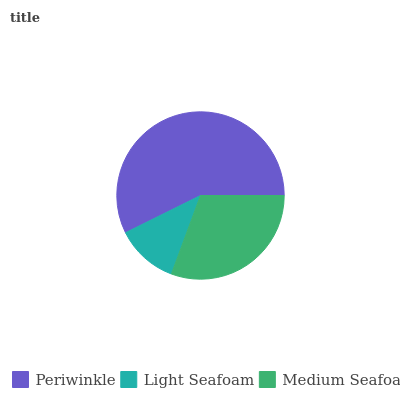Is Light Seafoam the minimum?
Answer yes or no. Yes. Is Periwinkle the maximum?
Answer yes or no. Yes. Is Medium Seafoam the minimum?
Answer yes or no. No. Is Medium Seafoam the maximum?
Answer yes or no. No. Is Medium Seafoam greater than Light Seafoam?
Answer yes or no. Yes. Is Light Seafoam less than Medium Seafoam?
Answer yes or no. Yes. Is Light Seafoam greater than Medium Seafoam?
Answer yes or no. No. Is Medium Seafoam less than Light Seafoam?
Answer yes or no. No. Is Medium Seafoam the high median?
Answer yes or no. Yes. Is Medium Seafoam the low median?
Answer yes or no. Yes. Is Light Seafoam the high median?
Answer yes or no. No. Is Periwinkle the low median?
Answer yes or no. No. 